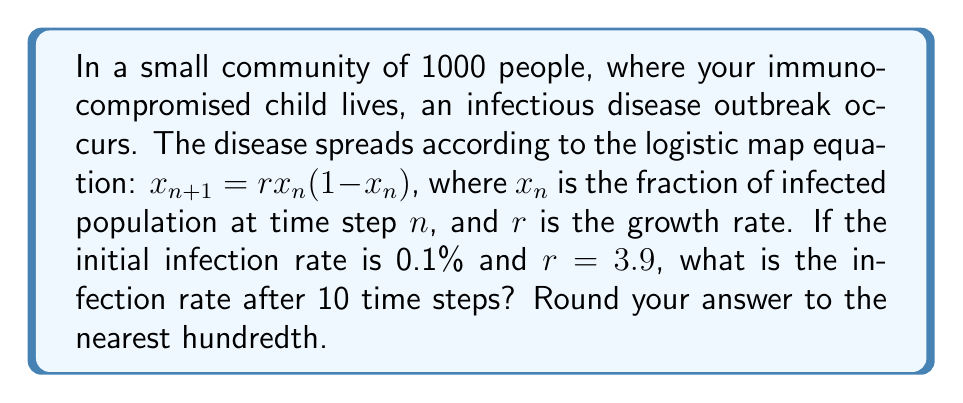Give your solution to this math problem. Let's approach this step-by-step using the logistic map equation:

1) Initial condition: $x_0 = 0.001$ (0.1% = 0.001)
2) $r = 3.9$
3) We need to iterate the equation 10 times:

   $x_1 = 3.9 \cdot 0.001 \cdot (1-0.001) = 0.003897$
   $x_2 = 3.9 \cdot 0.003897 \cdot (1-0.003897) = 0.015158$
   $x_3 = 3.9 \cdot 0.015158 \cdot (1-0.015158) = 0.058005$
   $x_4 = 3.9 \cdot 0.058005 \cdot (1-0.058005) = 0.212764$
   $x_5 = 3.9 \cdot 0.212764 \cdot (1-0.212764) = 0.652416$
   $x_6 = 3.9 \cdot 0.652416 \cdot (1-0.652416) = 0.883427$
   $x_7 = 3.9 \cdot 0.883427 \cdot (1-0.883427) = 0.401179$
   $x_8 = 3.9 \cdot 0.401179 \cdot (1-0.401179) = 0.935672$
   $x_9 = 3.9 \cdot 0.935672 \cdot (1-0.935672) = 0.234823$
   $x_{10} = 3.9 \cdot 0.234823 \cdot (1-0.234823) = 0.699706$

4) Converting to a percentage and rounding to the nearest hundredth:
   $0.699706 \cdot 100 \approx 69.97\%$

This demonstrates the butterfly effect in disease spread, where a small initial infection leads to a large, unpredictable outbreak over time.
Answer: 69.97% 